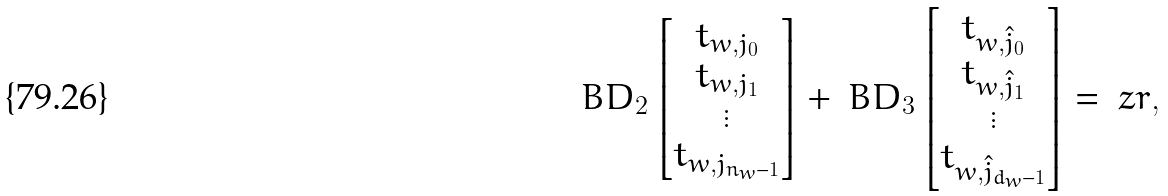Convert formula to latex. <formula><loc_0><loc_0><loc_500><loc_500>\ B D _ { 2 } \begin{bmatrix} t _ { w , j _ { 0 } } \\ t _ { w , j _ { 1 } } \\ \vdots \\ t _ { w , j _ { n _ { w } - 1 } } \end{bmatrix} + \ B D _ { 3 } \begin{bmatrix} t _ { w , \hat { j } _ { 0 } } \\ t _ { w , \hat { j } _ { 1 } } \\ \vdots \\ t _ { w , \hat { j } _ { d _ { w } - 1 } } \end{bmatrix} = \ z r ,</formula> 